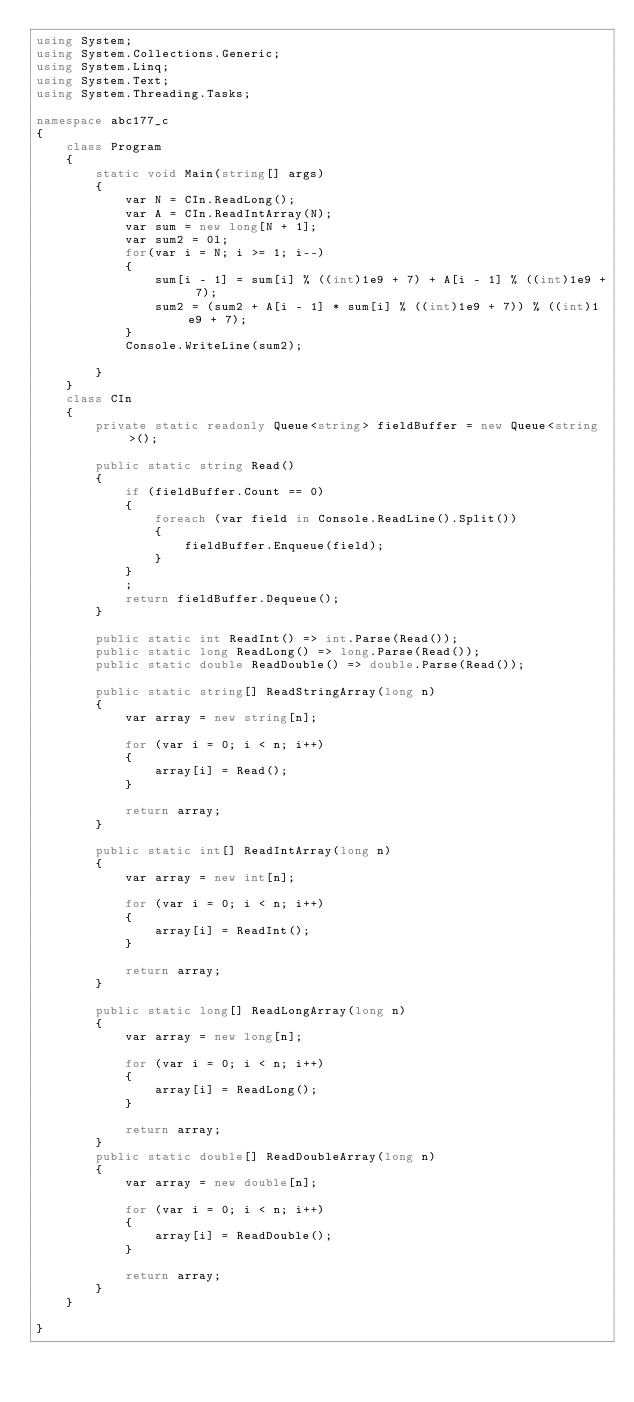Convert code to text. <code><loc_0><loc_0><loc_500><loc_500><_C#_>using System;
using System.Collections.Generic;
using System.Linq;
using System.Text;
using System.Threading.Tasks;

namespace abc177_c
{
    class Program
    {
        static void Main(string[] args)
        {
            var N = CIn.ReadLong();
            var A = CIn.ReadIntArray(N);
            var sum = new long[N + 1];
            var sum2 = 0l;
            for(var i = N; i >= 1; i--)
            {
                sum[i - 1] = sum[i] % ((int)1e9 + 7) + A[i - 1] % ((int)1e9 + 7);
                sum2 = (sum2 + A[i - 1] * sum[i] % ((int)1e9 + 7)) % ((int)1e9 + 7);
            }
            Console.WriteLine(sum2);
            
        }
    }
    class CIn
    {
        private static readonly Queue<string> fieldBuffer = new Queue<string>();

        public static string Read()
        {
            if (fieldBuffer.Count == 0)
            {
                foreach (var field in Console.ReadLine().Split())
                {
                    fieldBuffer.Enqueue(field);
                }
            }
            ;
            return fieldBuffer.Dequeue();
        }

        public static int ReadInt() => int.Parse(Read());
        public static long ReadLong() => long.Parse(Read());
        public static double ReadDouble() => double.Parse(Read());

        public static string[] ReadStringArray(long n)
        {
            var array = new string[n];

            for (var i = 0; i < n; i++)
            {
                array[i] = Read();
            }

            return array;
        }

        public static int[] ReadIntArray(long n)
        {
            var array = new int[n];

            for (var i = 0; i < n; i++)
            {
                array[i] = ReadInt();
            }

            return array;
        }

        public static long[] ReadLongArray(long n)
        {
            var array = new long[n];

            for (var i = 0; i < n; i++)
            {
                array[i] = ReadLong();
            }

            return array;
        }
        public static double[] ReadDoubleArray(long n)
        {
            var array = new double[n];

            for (var i = 0; i < n; i++)
            {
                array[i] = ReadDouble();
            }

            return array;
        }
    }

}
</code> 